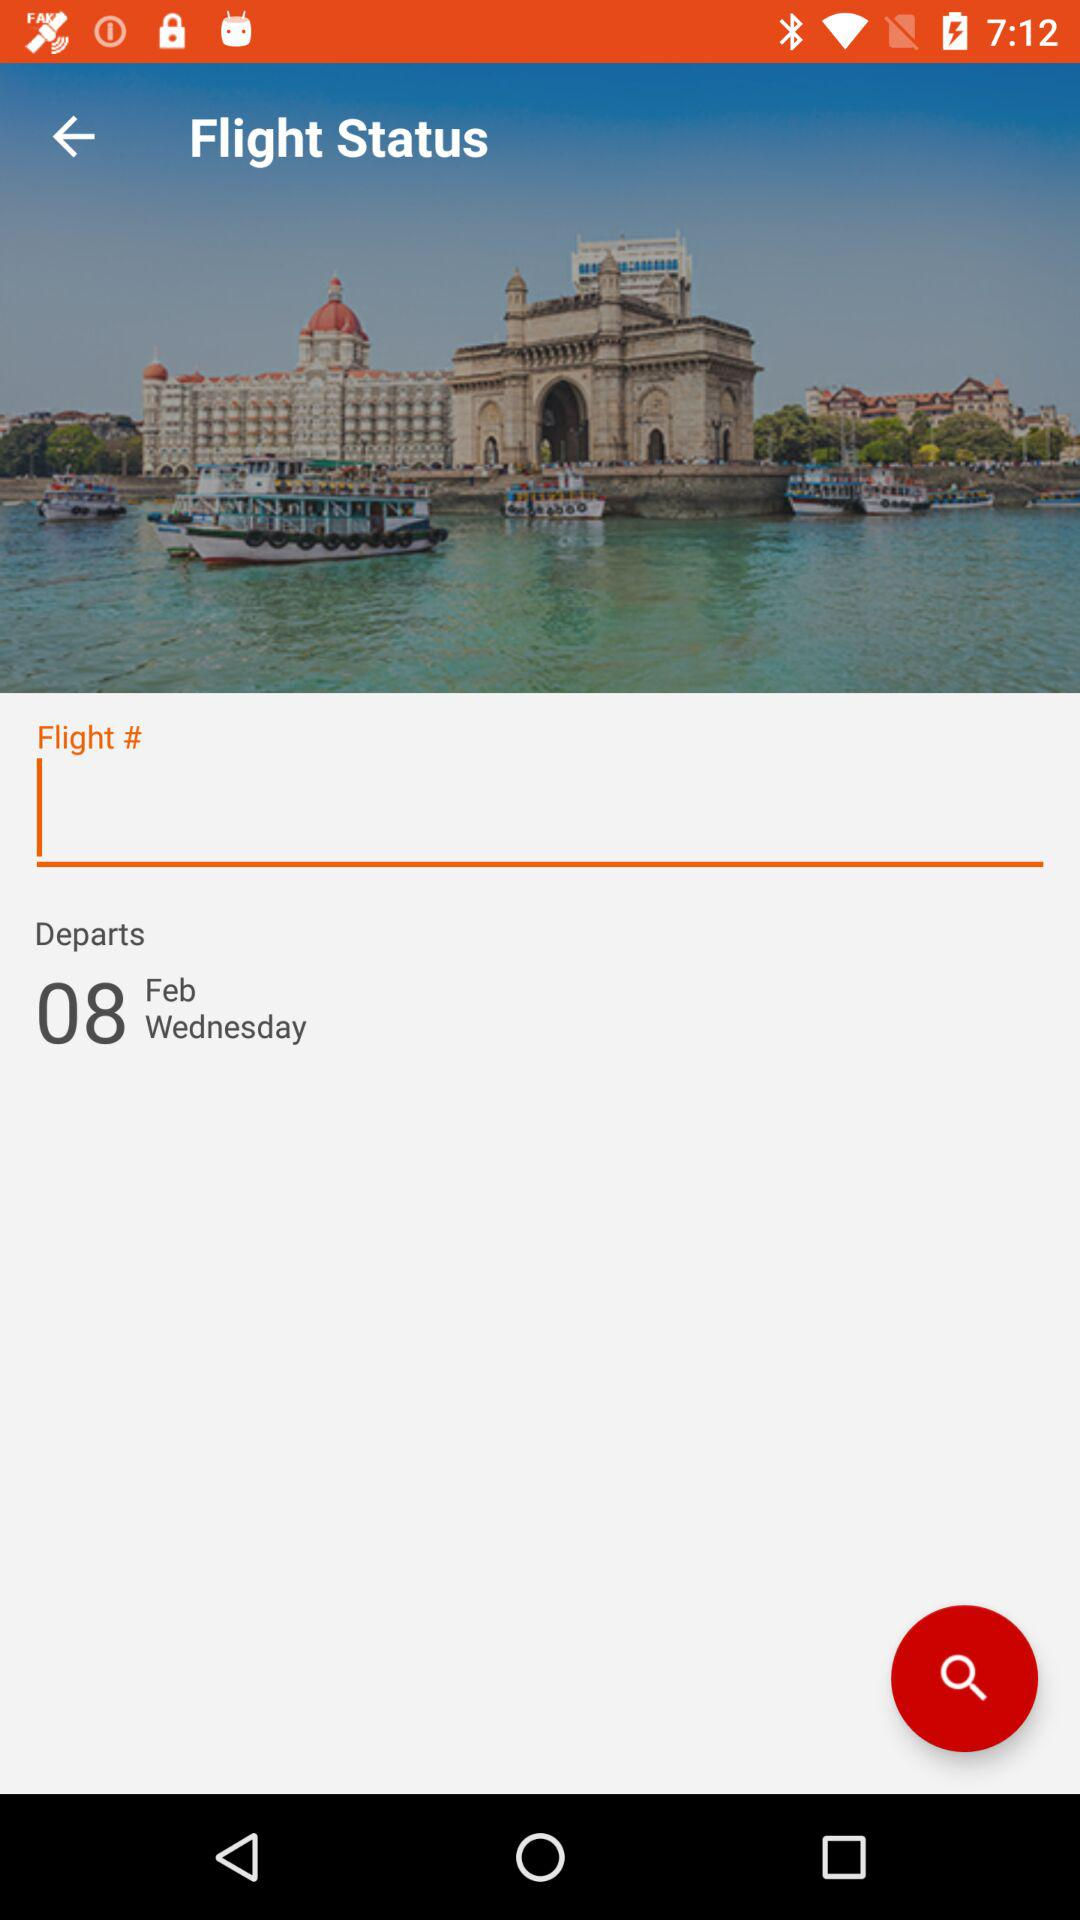What is the flight number?
When the provided information is insufficient, respond with <no answer>. <no answer> 